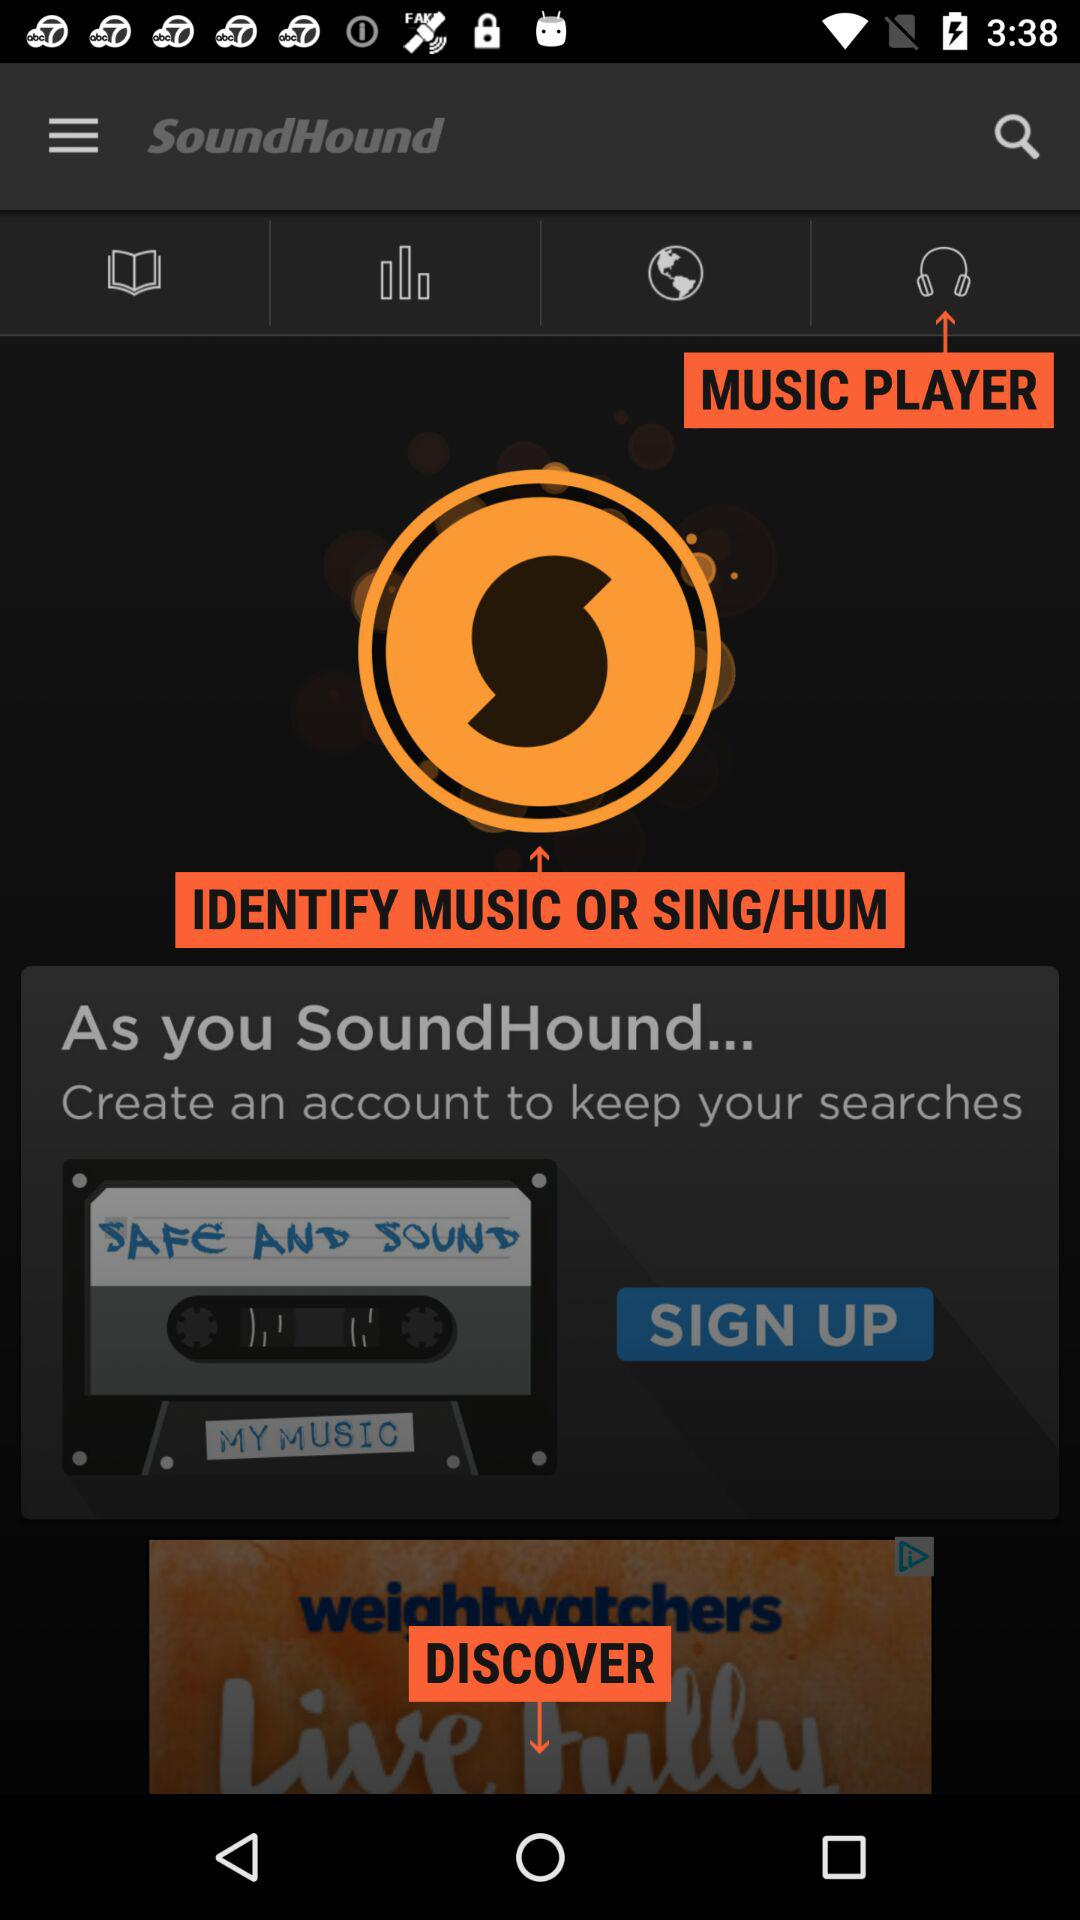What is the name of the application? The name of the application is "SoundHound". 